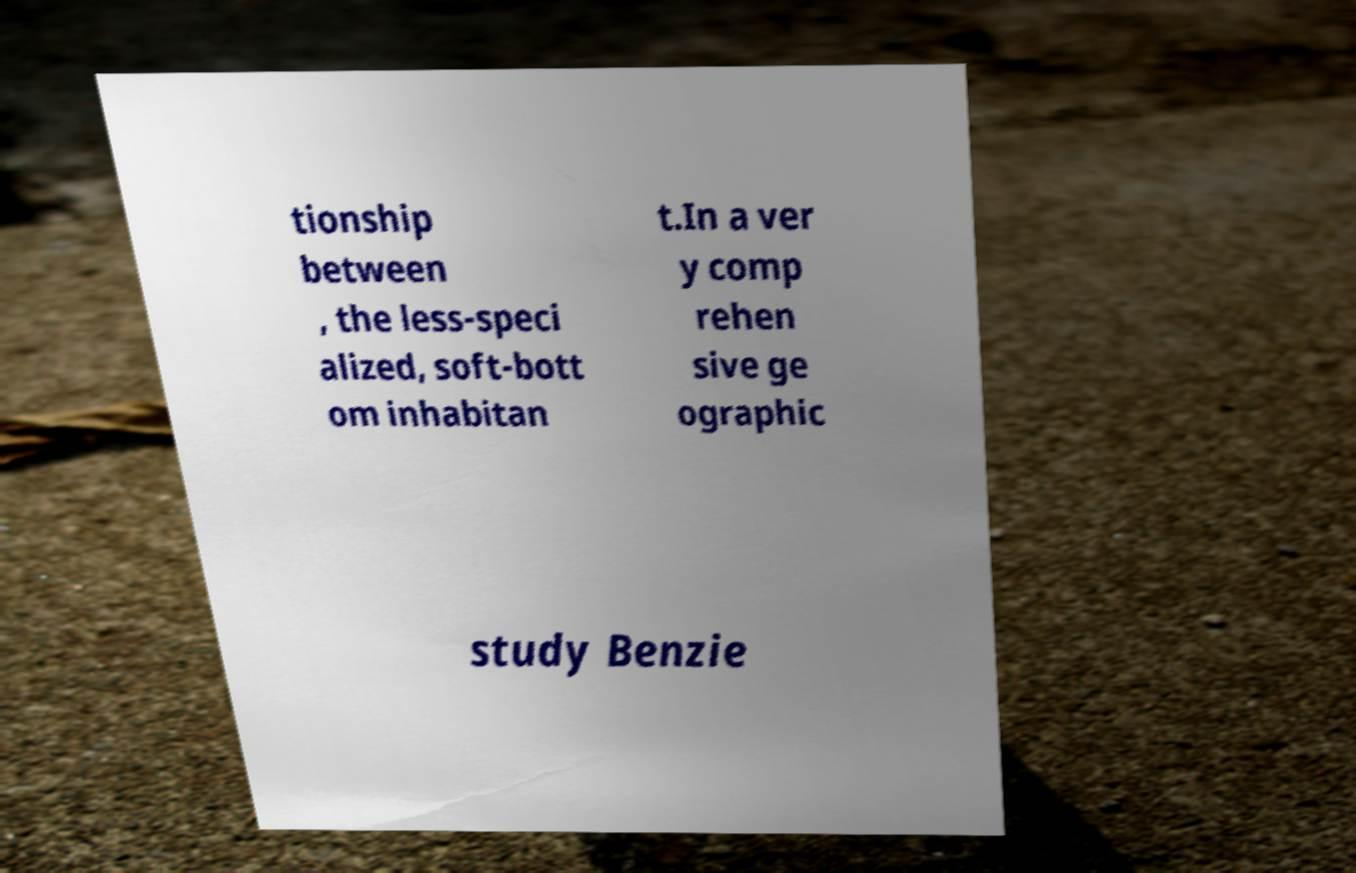Please identify and transcribe the text found in this image. tionship between , the less-speci alized, soft-bott om inhabitan t.In a ver y comp rehen sive ge ographic study Benzie 